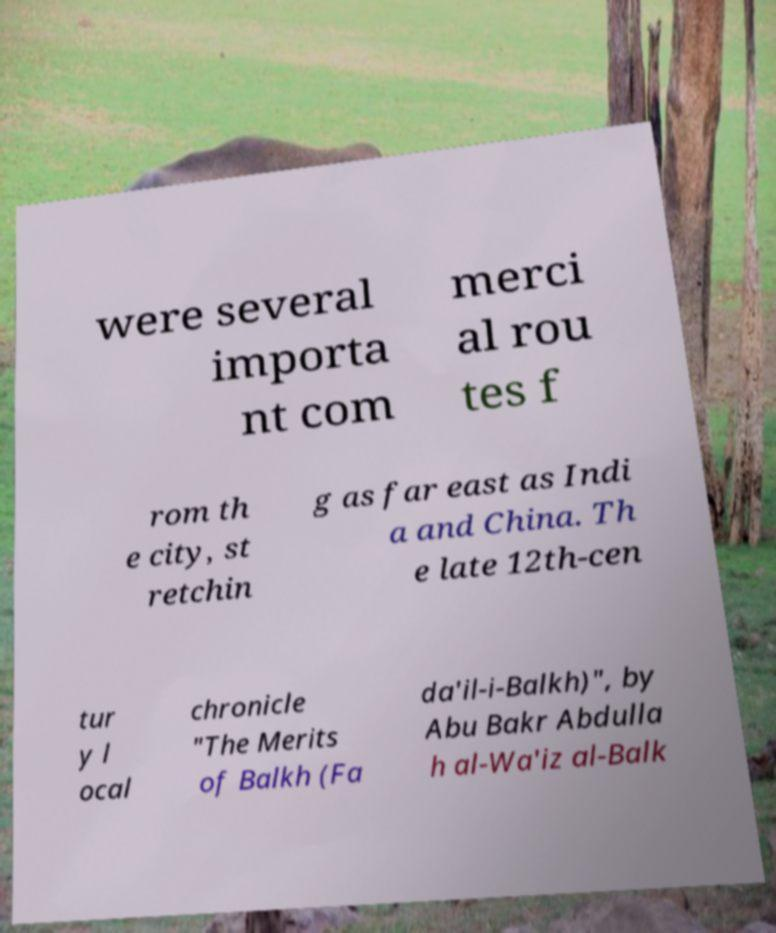Could you extract and type out the text from this image? were several importa nt com merci al rou tes f rom th e city, st retchin g as far east as Indi a and China. Th e late 12th-cen tur y l ocal chronicle "The Merits of Balkh (Fa da'il-i-Balkh)", by Abu Bakr Abdulla h al-Wa'iz al-Balk 